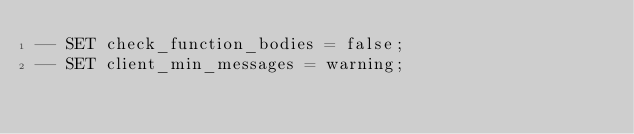<code> <loc_0><loc_0><loc_500><loc_500><_SQL_>-- SET check_function_bodies = false;
-- SET client_min_messages = warning;</code> 